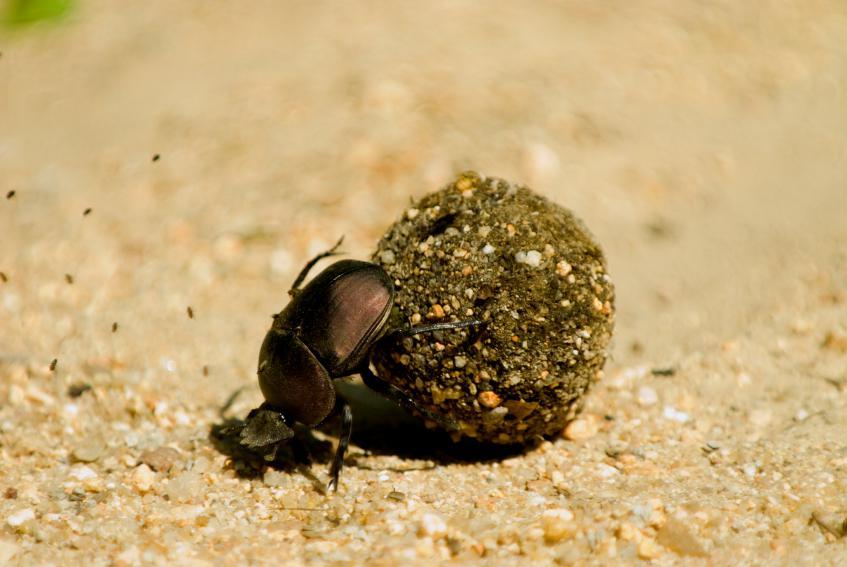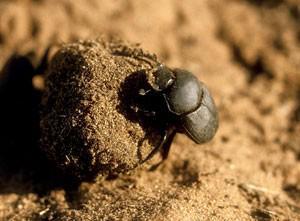The first image is the image on the left, the second image is the image on the right. Assess this claim about the two images: "The image contains two beatles". Correct or not? Answer yes or no. Yes. 